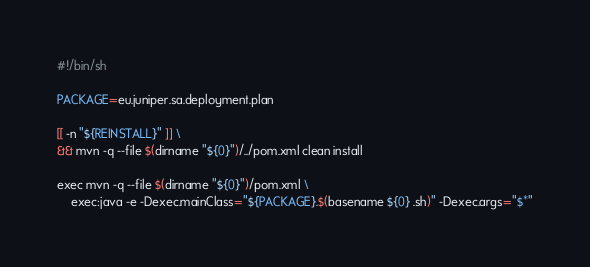Convert code to text. <code><loc_0><loc_0><loc_500><loc_500><_Bash_>#!/bin/sh

PACKAGE=eu.juniper.sa.deployment.plan

[[ -n "${REINSTALL}" ]] \
&& mvn -q --file $(dirname "${0}")/../pom.xml clean install

exec mvn -q --file $(dirname "${0}")/pom.xml \
	exec:java -e -Dexec.mainClass="${PACKAGE}.$(basename ${0} .sh)" -Dexec.args="$*"
</code> 